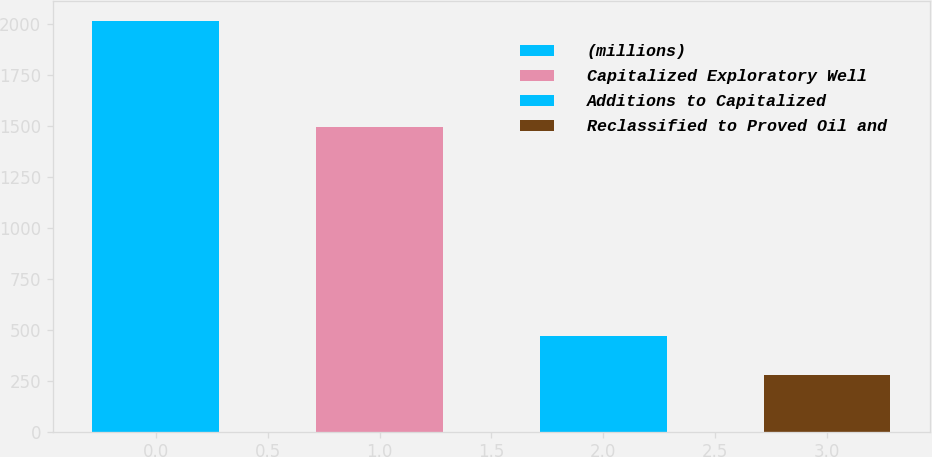Convert chart. <chart><loc_0><loc_0><loc_500><loc_500><bar_chart><fcel>(millions)<fcel>Capitalized Exploratory Well<fcel>Additions to Capitalized<fcel>Reclassified to Proved Oil and<nl><fcel>2014<fcel>1494<fcel>470<fcel>277<nl></chart> 